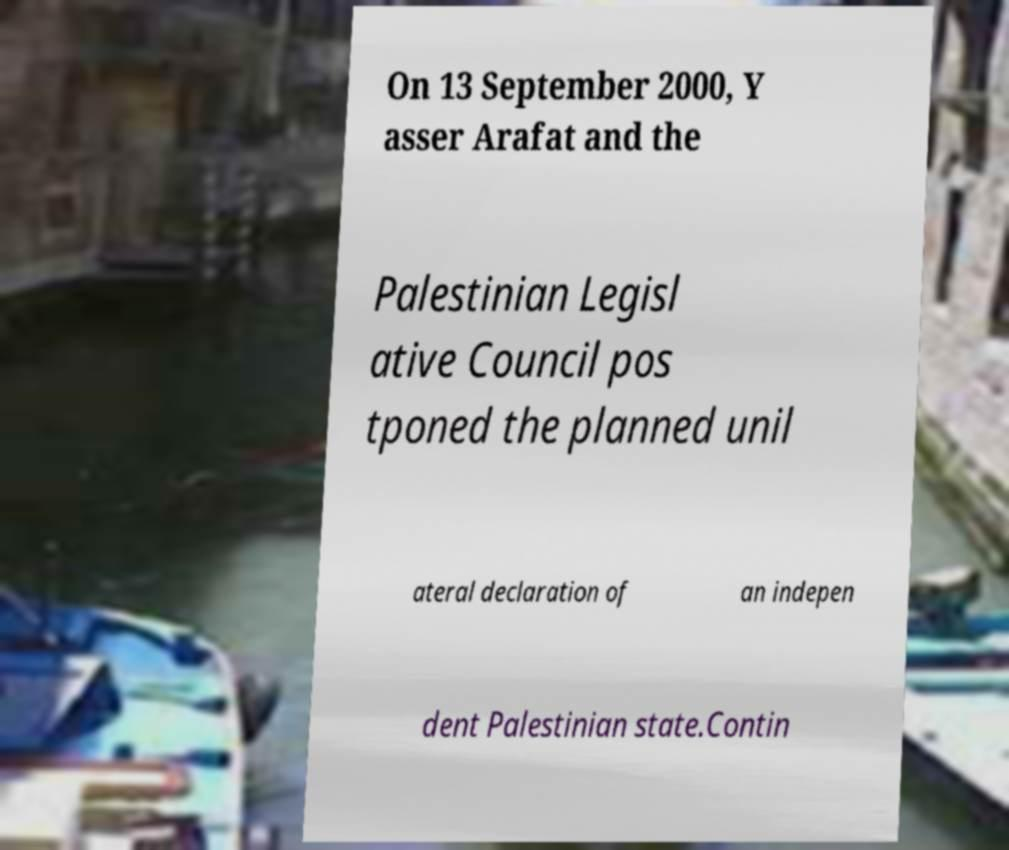For documentation purposes, I need the text within this image transcribed. Could you provide that? On 13 September 2000, Y asser Arafat and the Palestinian Legisl ative Council pos tponed the planned unil ateral declaration of an indepen dent Palestinian state.Contin 